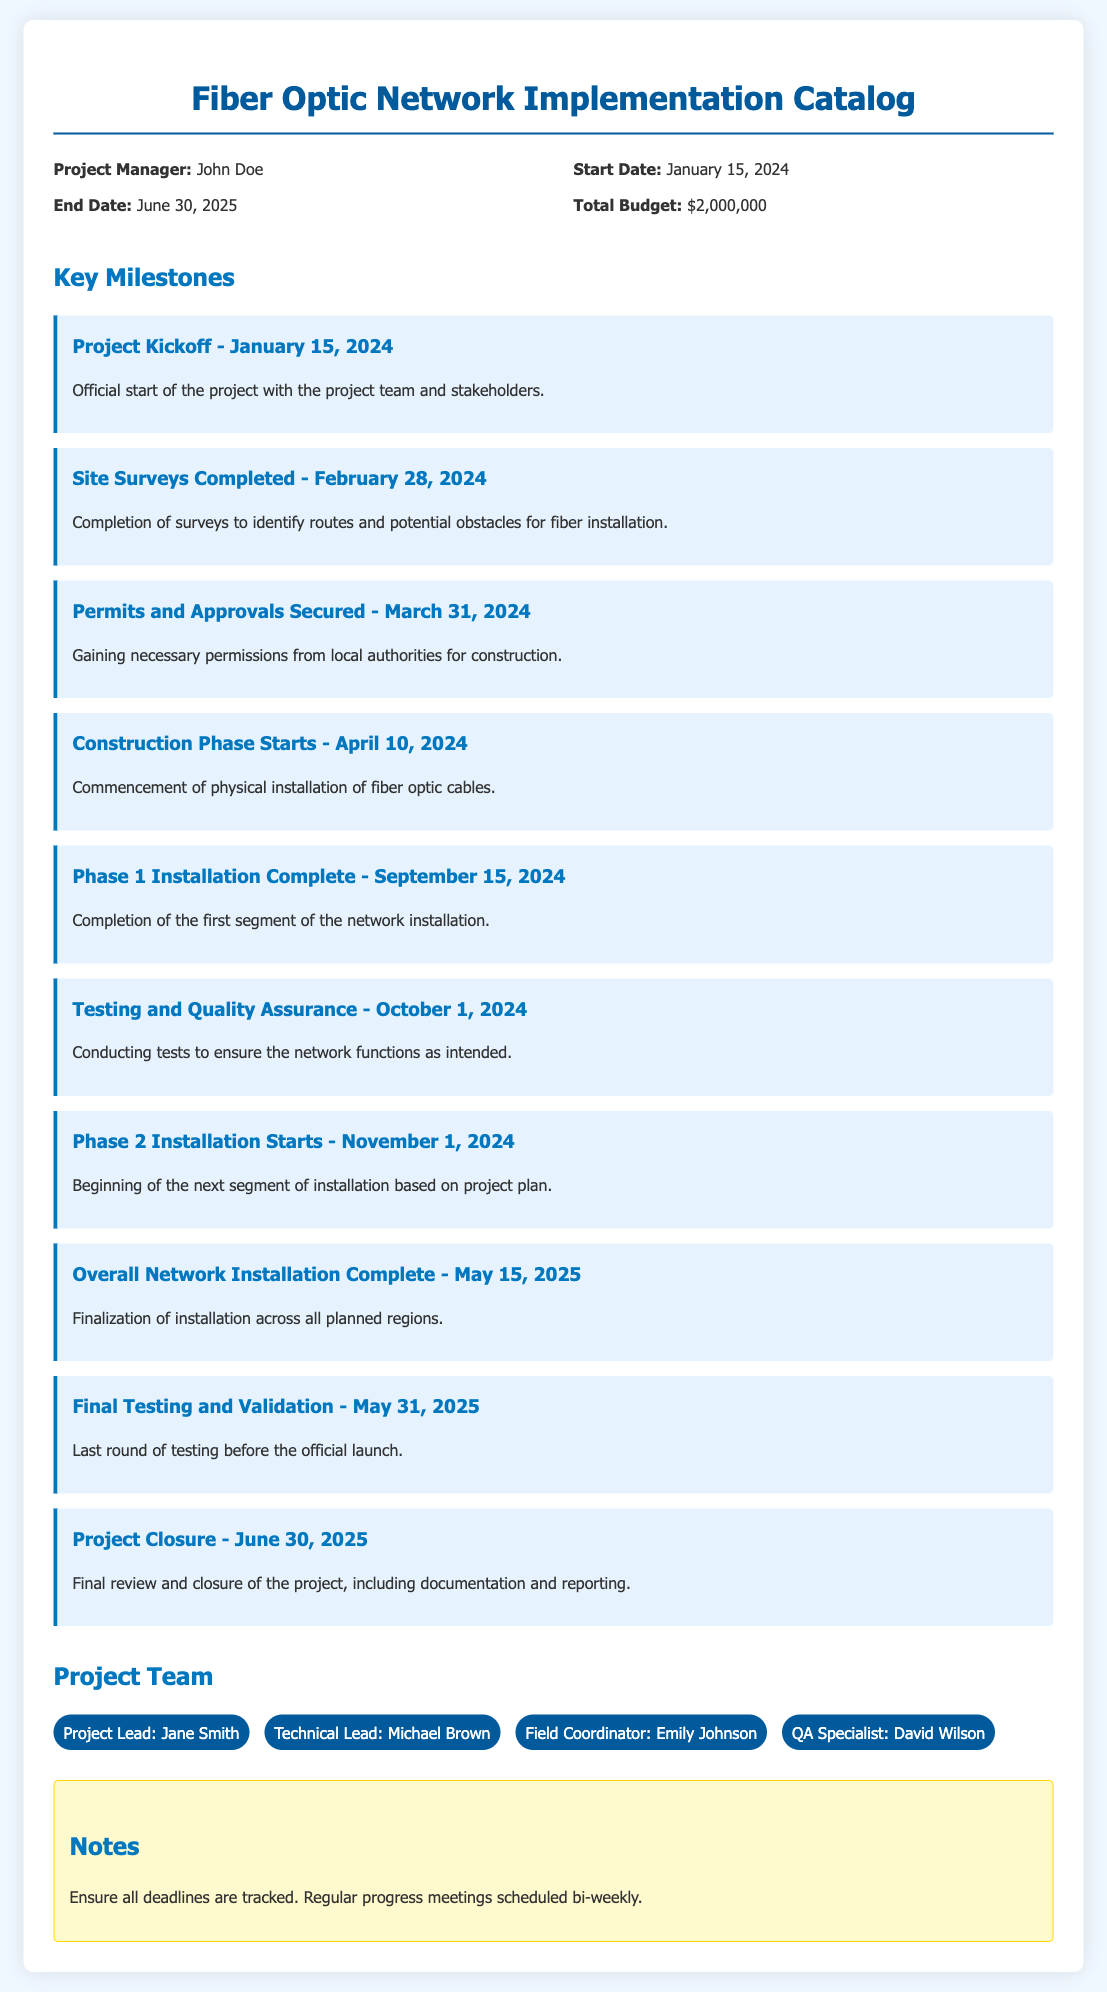What is the project manager's name? The project manager's name is listed under project information in the document.
Answer: John Doe When does the project officially start? The official start date is mentioned in the project information section.
Answer: January 15, 2024 What is the total budget for the project? The total budget is stated in the project information.
Answer: $2,000,000 When is the overall network installation completion date? This date is found in the key milestones section under overall network installation complete.
Answer: May 15, 2025 How many phases are there in the installation? Based on the milestones outlined, there are two identified phases of installation.
Answer: 2 What is the deadline for final testing and validation? This deadline is specified in the key milestones.
Answer: May 31, 2025 Who is the Technical Lead? The name of the technical lead is provided in the project team section of the document.
Answer: Michael Brown What is the date for the project closure? The closure date is listed under the key milestones section.
Answer: June 30, 2025 What is the main purpose of conducting testing and quality assurance? This purpose is generally addressed in the milestones section regarding network functionality.
Answer: Ensure the network functions as intended 